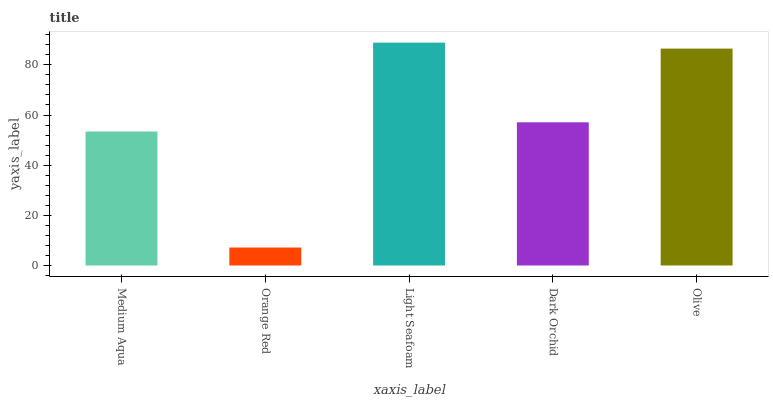Is Orange Red the minimum?
Answer yes or no. Yes. Is Light Seafoam the maximum?
Answer yes or no. Yes. Is Light Seafoam the minimum?
Answer yes or no. No. Is Orange Red the maximum?
Answer yes or no. No. Is Light Seafoam greater than Orange Red?
Answer yes or no. Yes. Is Orange Red less than Light Seafoam?
Answer yes or no. Yes. Is Orange Red greater than Light Seafoam?
Answer yes or no. No. Is Light Seafoam less than Orange Red?
Answer yes or no. No. Is Dark Orchid the high median?
Answer yes or no. Yes. Is Dark Orchid the low median?
Answer yes or no. Yes. Is Orange Red the high median?
Answer yes or no. No. Is Olive the low median?
Answer yes or no. No. 